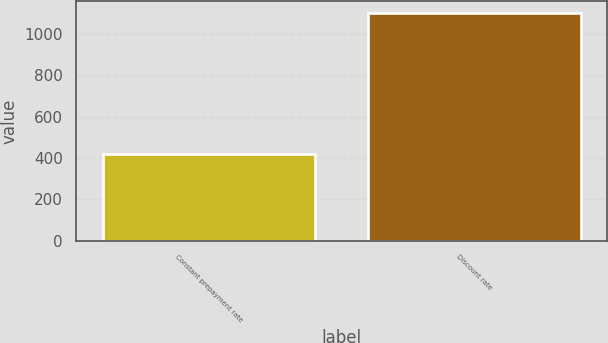Convert chart. <chart><loc_0><loc_0><loc_500><loc_500><bar_chart><fcel>Constant prepayment rate<fcel>Discount rate<nl><fcel>419<fcel>1102<nl></chart> 